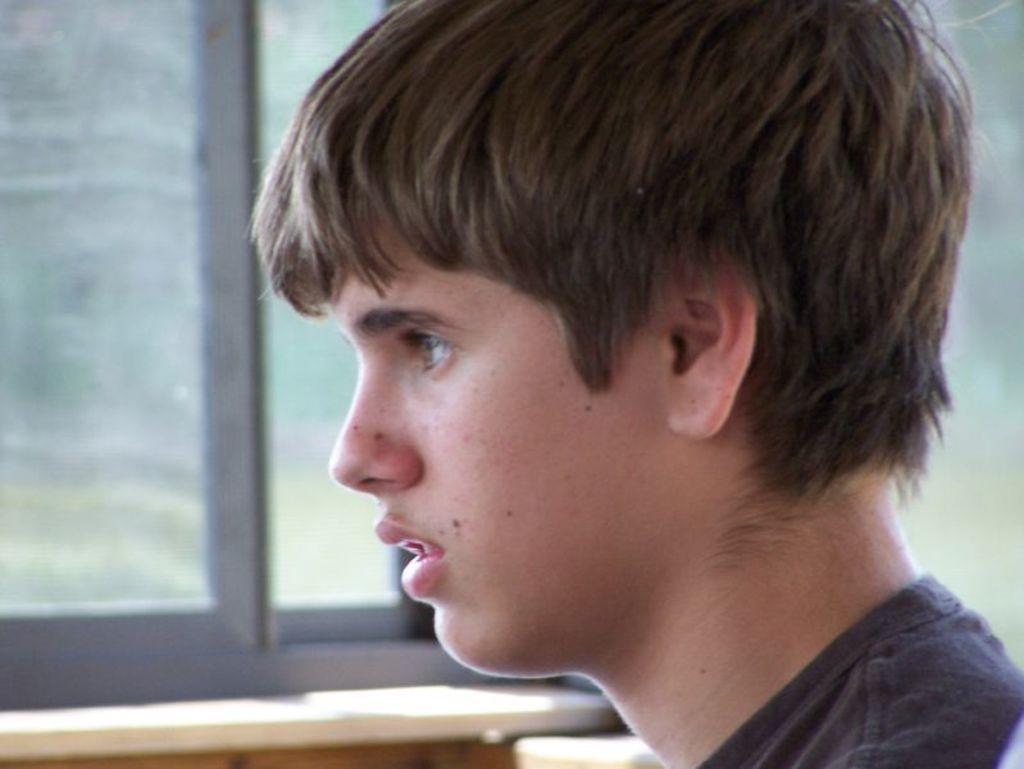What is the main subject of the image? There is a person in the image. What can be seen in the background of the image? There is a window in the background of the image. How does the person control the birth of the newborn in the image? There is no newborn or indication of childbirth in the image; it only features a person and a window. 